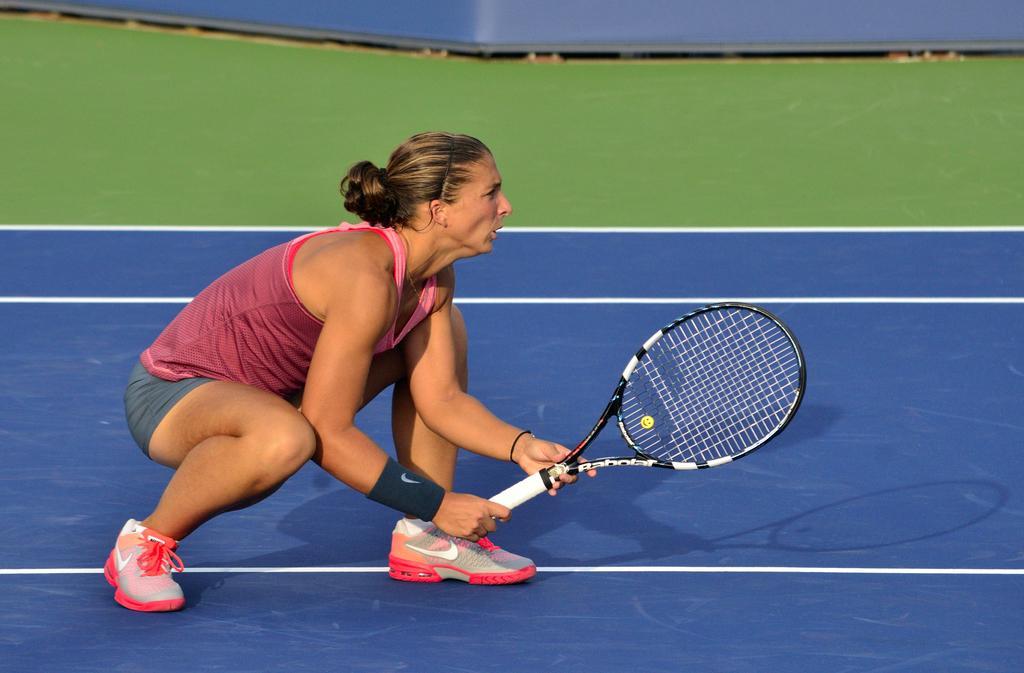In one or two sentences, can you explain what this image depicts? A lady is in squad position holding a badminton racket. She is wearing shoes. she is on the court. 